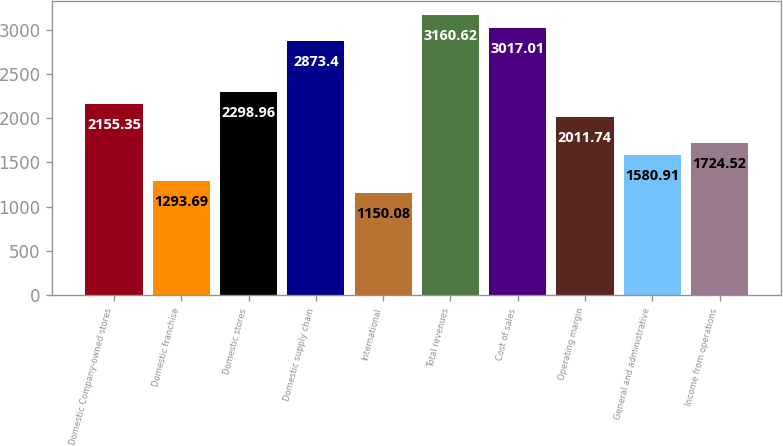Convert chart. <chart><loc_0><loc_0><loc_500><loc_500><bar_chart><fcel>Domestic Company-owned stores<fcel>Domestic franchise<fcel>Domestic stores<fcel>Domestic supply chain<fcel>International<fcel>Total revenues<fcel>Cost of sales<fcel>Operating margin<fcel>General and administrative<fcel>Income from operations<nl><fcel>2155.35<fcel>1293.69<fcel>2298.96<fcel>2873.4<fcel>1150.08<fcel>3160.62<fcel>3017.01<fcel>2011.74<fcel>1580.91<fcel>1724.52<nl></chart> 